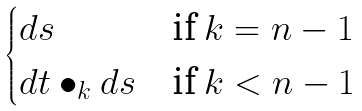<formula> <loc_0><loc_0><loc_500><loc_500>\begin{cases} d s & \text {if } k = n - 1 \\ d t \bullet _ { k } d s & \text {if } k < n - 1 \end{cases}</formula> 